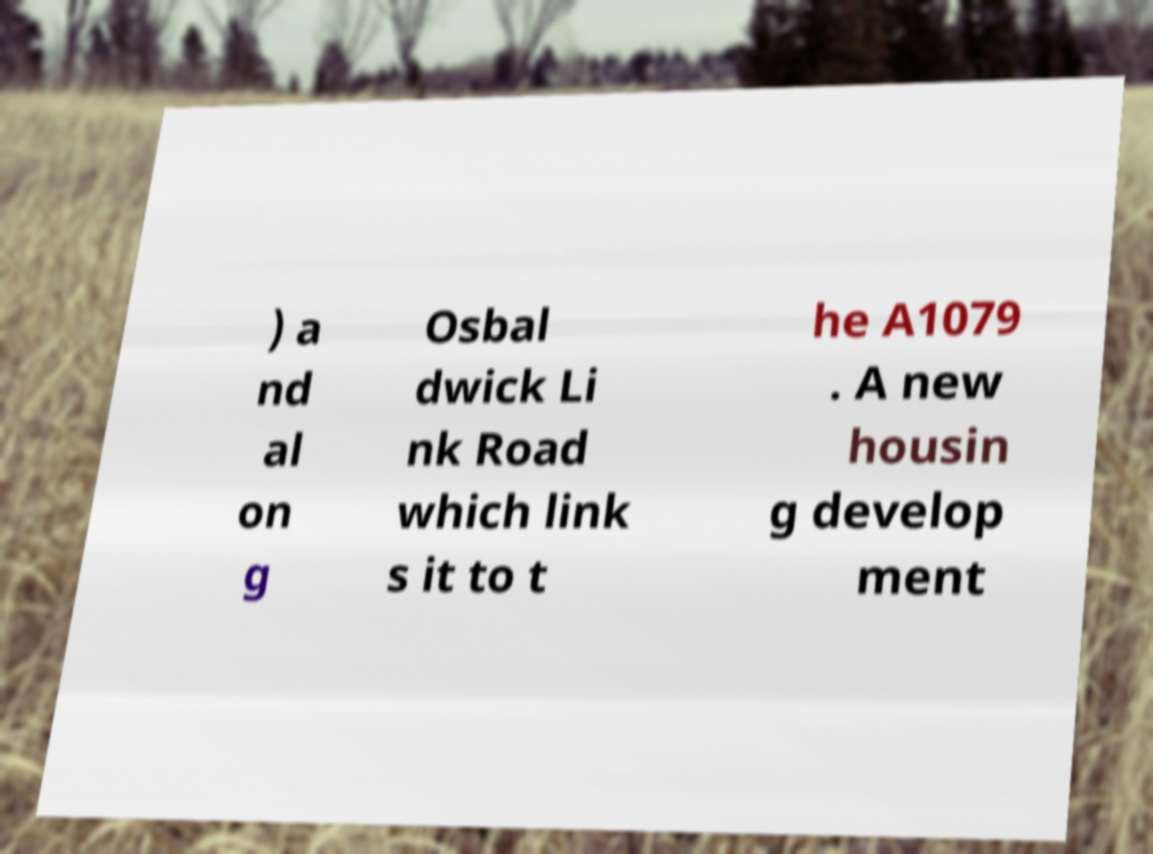What messages or text are displayed in this image? I need them in a readable, typed format. ) a nd al on g Osbal dwick Li nk Road which link s it to t he A1079 . A new housin g develop ment 